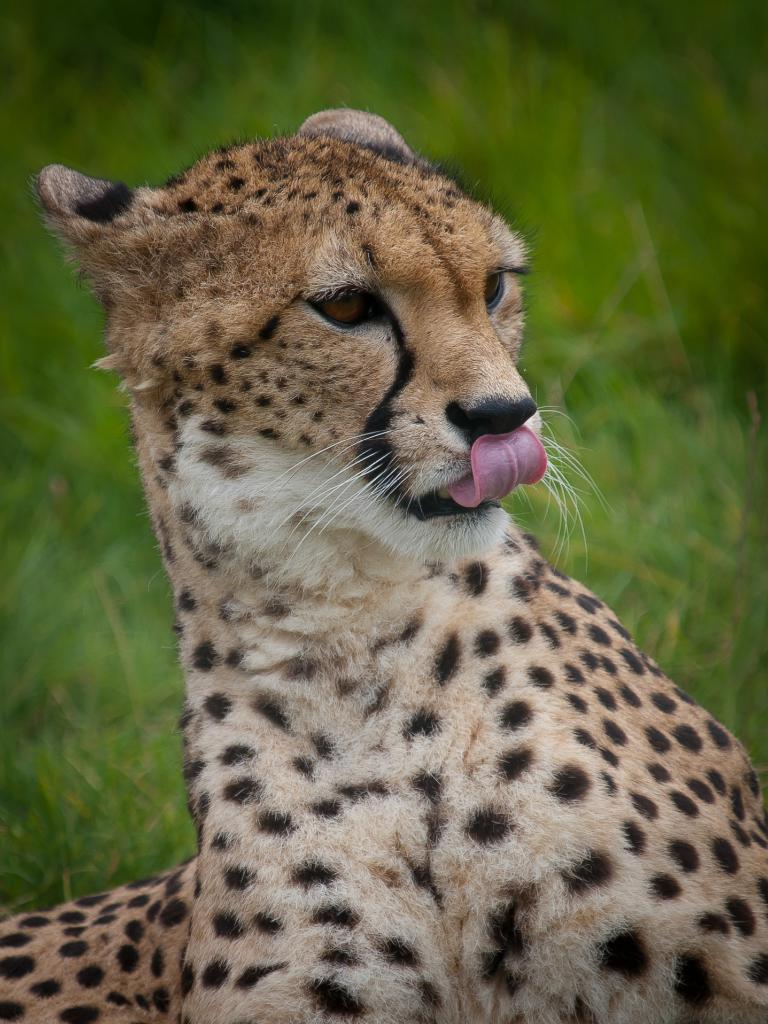What type of animal is in the image? The animal in the image has brown and black coloring, but the specific type cannot be determined from the provided facts. What is the color of the animal's fur? The animal has brown and black coloring. What can be seen in the background of the image? The background of the image includes green grass. What brand of toothpaste is the animal using in the image? There is no toothpaste or any indication of tooth brushing in the image. 